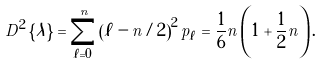<formula> <loc_0><loc_0><loc_500><loc_500>D ^ { 2 } \left \{ \lambda \right \} = \sum _ { \ell = 0 } ^ { n } \left ( \ell - n / 2 \right ) ^ { 2 } p _ { \ell } = \frac { 1 } { 6 } n \left ( 1 + \frac { 1 } { 2 } n \right ) .</formula> 